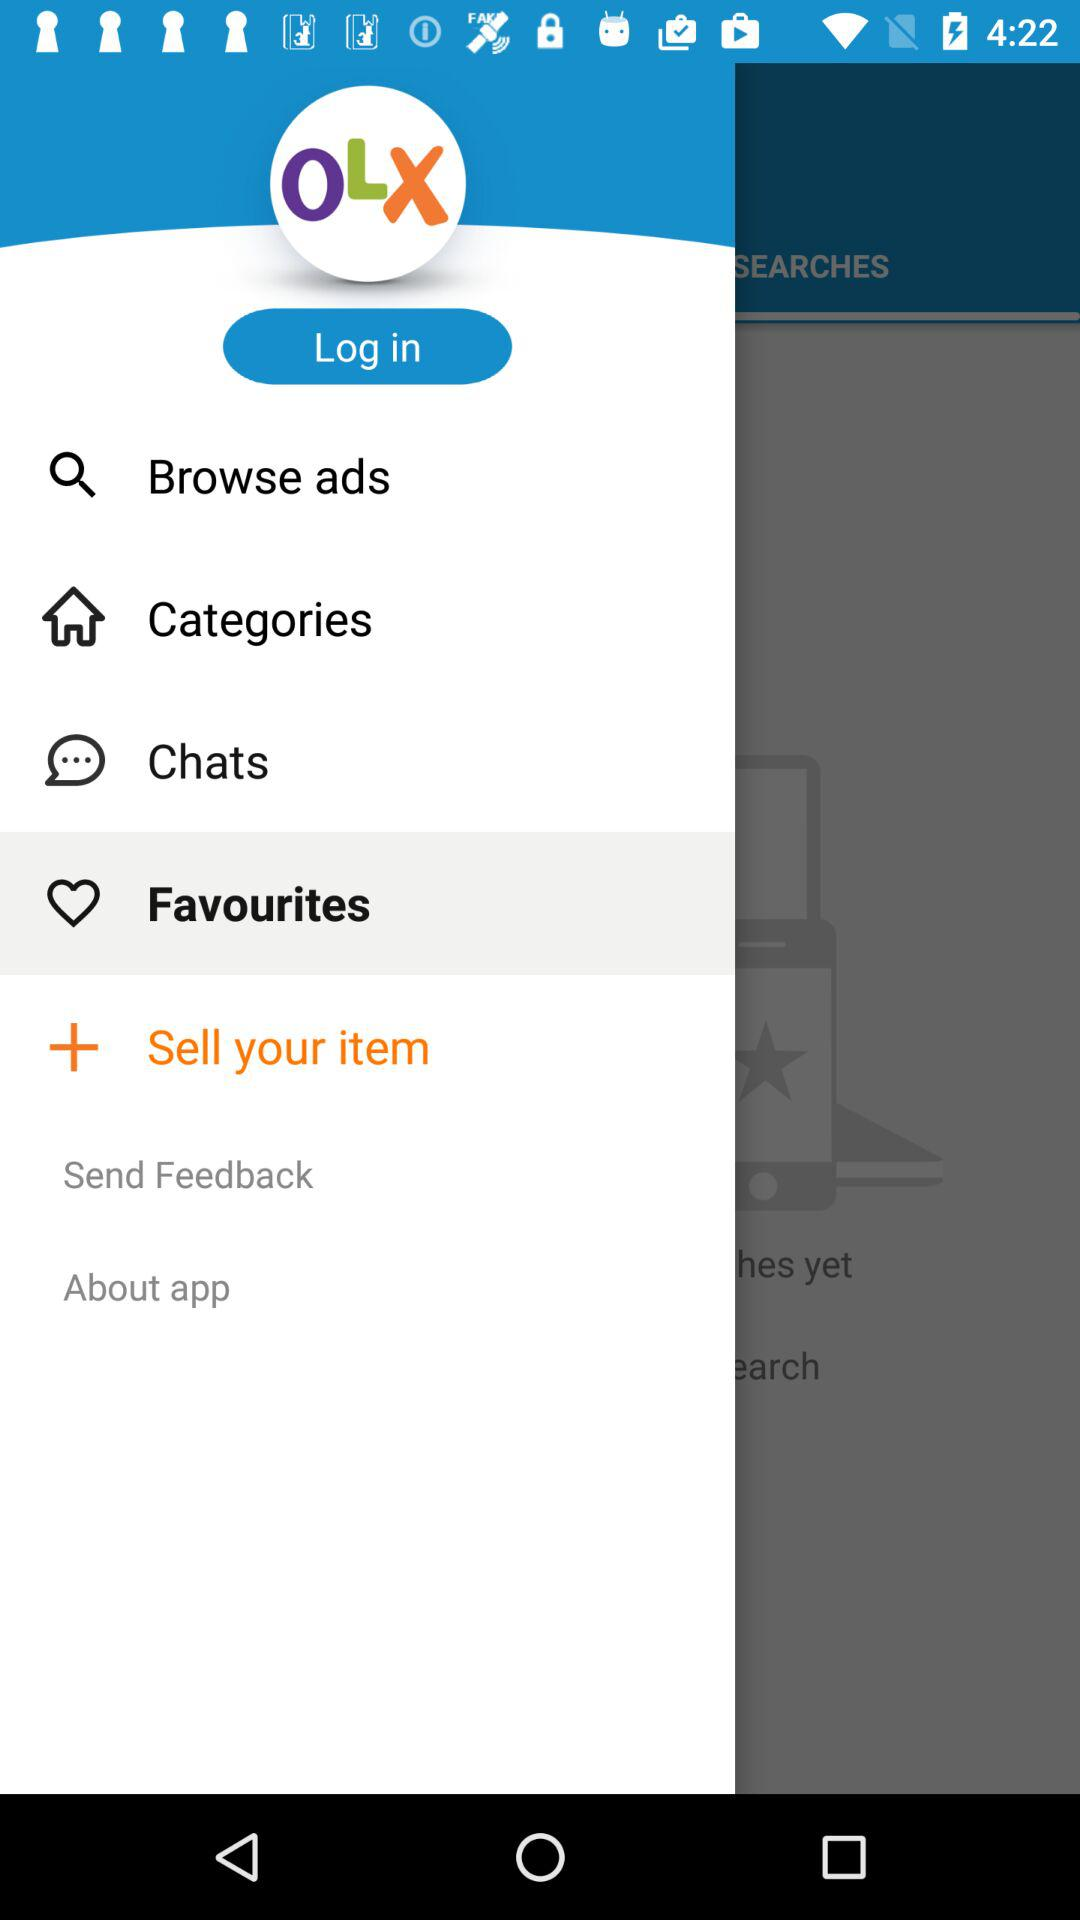What is the name of the application? The name of the application is "OLX". 